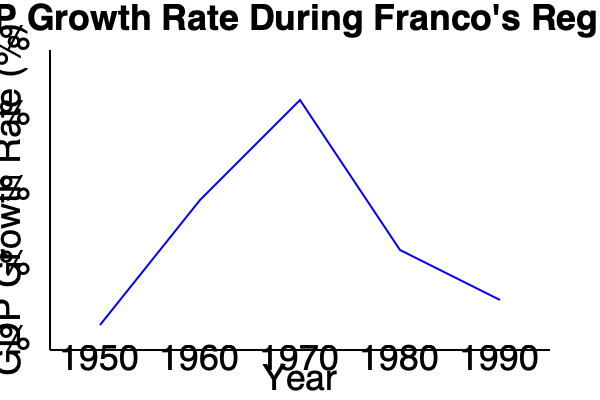Based on the line graph depicting GDP growth rates during Franco's regime, which decade showed the highest average economic growth, and what factors might have contributed to this period of expansion? To answer this question, we need to analyze the GDP growth rate trend shown in the graph and consider the historical context of Franco's regime:

1. Observe the graph: The line represents GDP growth rates from 1950 to 1990.

2. Identify the highest point: The peak of the graph occurs around 1970, indicating the highest growth rate.

3. Analyze by decade:
   - 1950s: Growth starts low but increases steadily
   - 1960s: Rapid increase in growth rate, reaching the peak
   - 1970s: High growth rate at the beginning, then declining
   - 1980s: Lower growth rate compared to the 1960s and early 1970s

4. Determine the decade with highest average growth: The 1960s show the steepest and most consistent upward trend.

5. Consider historical factors for the 1960s expansion:
   a. Economic liberalization: The "Spanish Miracle" began in the late 1950s
   b. Stabilization Plan of 1959: Opened Spain to foreign investment
   c. Tourism boom: Increased foreign currency inflows
   d. Industrial development: Focus on manufacturing and exports
   e. Technocratic policies: Implementation of more market-oriented economic policies

6. Contextualize within Franco's regime:
   - Early years (1940s-1950s): Autarky and economic isolation
   - Middle period (1960s-early 1970s): Economic liberalization and growth
   - Later years (mid-1970s-1975): Slowing growth due to oil crisis and political uncertainty

The 1960s marked a significant shift from the earlier isolationist policies, leading to rapid economic growth and modernization in Spain.
Answer: The 1960s; economic liberalization, foreign investment, tourism, and technocratic policies. 